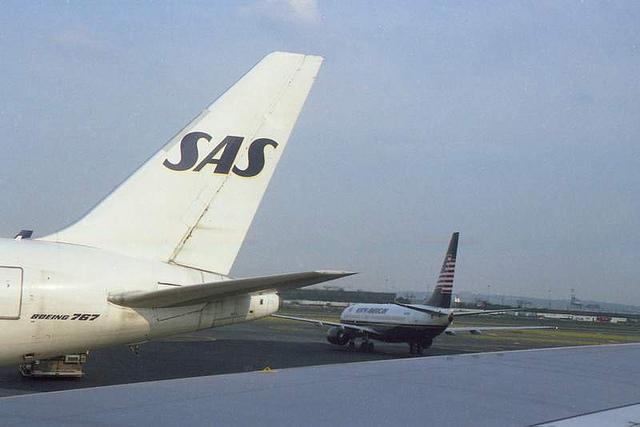What letters are on the plane?
Short answer required. Sas. Are these planes in flight?
Give a very brief answer. No. Are clouds visible?
Short answer required. Yes. How many planes are in the picture?
Quick response, please. 2. 